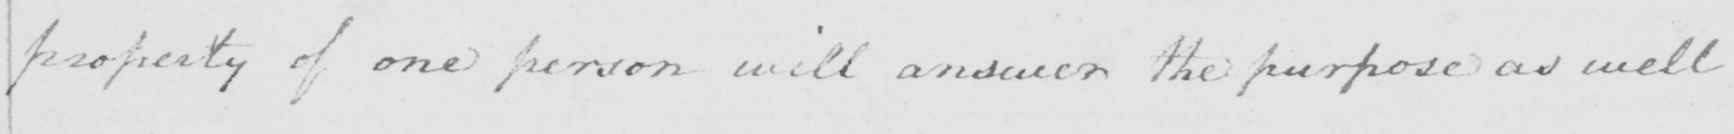Can you read and transcribe this handwriting? property of one person will answer the purpose as well 